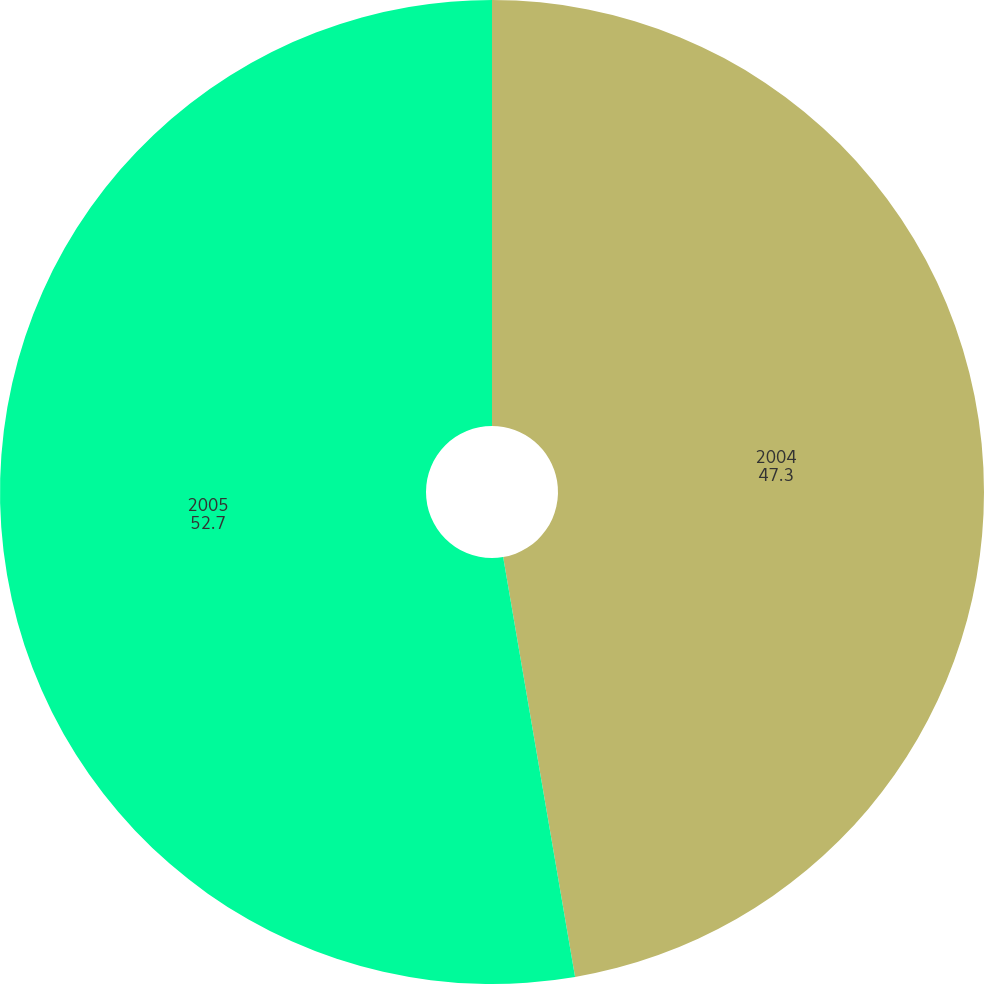Convert chart. <chart><loc_0><loc_0><loc_500><loc_500><pie_chart><fcel>2004<fcel>2005<nl><fcel>47.3%<fcel>52.7%<nl></chart> 